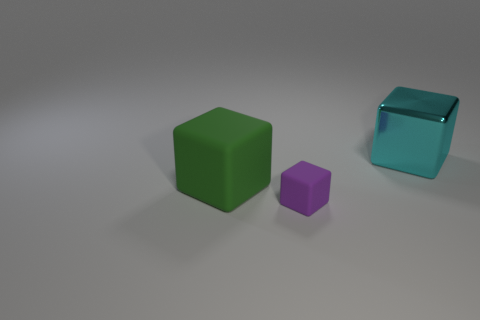Are there any other things that are the same size as the purple rubber object?
Keep it short and to the point. No. There is a large object that is in front of the large object behind the large block that is in front of the cyan object; what color is it?
Give a very brief answer. Green. Does the thing that is on the left side of the purple block have the same material as the object to the right of the small thing?
Provide a succinct answer. No. How many things are either large things in front of the cyan cube or cyan metal blocks?
Make the answer very short. 2. How many objects are purple matte objects or tiny purple matte blocks on the left side of the big cyan cube?
Your answer should be very brief. 1. What number of other green rubber blocks have the same size as the green block?
Your answer should be compact. 0. Are there fewer cyan blocks that are right of the green block than blocks that are behind the purple cube?
Your answer should be compact. Yes. How many metal objects are either cyan objects or small blocks?
Provide a short and direct response. 1. There is a cube that is the same size as the green matte thing; what material is it?
Keep it short and to the point. Metal. What number of big objects are either brown cylinders or blocks?
Provide a succinct answer. 2. 